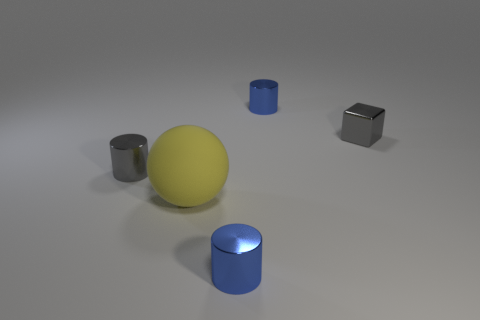Add 1 gray shiny things. How many objects exist? 6 Subtract all balls. How many objects are left? 4 Add 5 big yellow things. How many big yellow things are left? 6 Add 1 big spheres. How many big spheres exist? 2 Subtract 1 yellow balls. How many objects are left? 4 Subtract all small purple cubes. Subtract all gray objects. How many objects are left? 3 